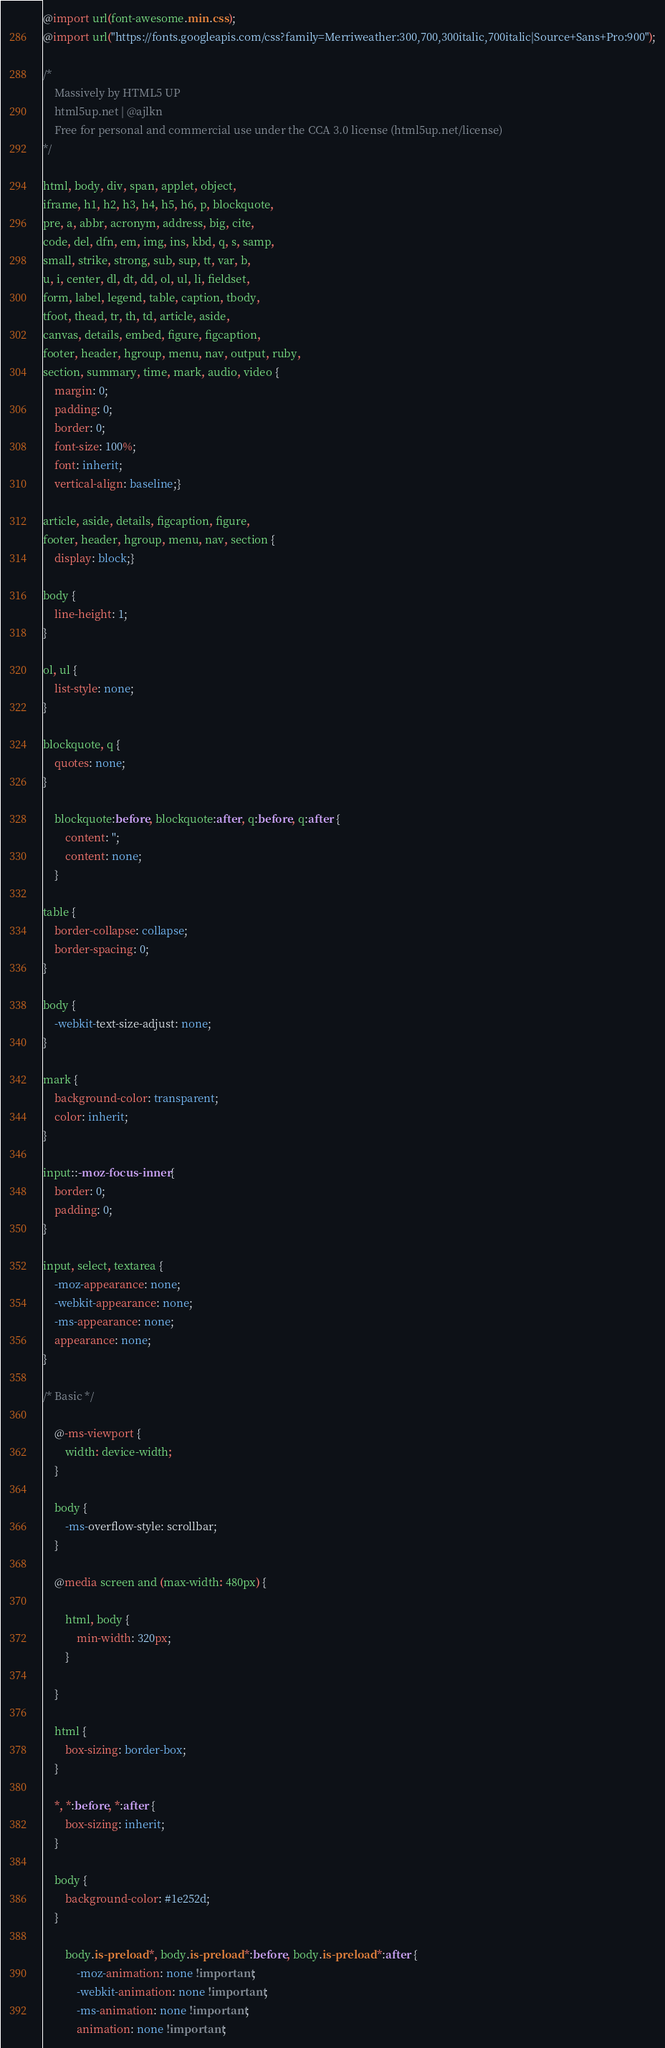<code> <loc_0><loc_0><loc_500><loc_500><_CSS_>@import url(font-awesome.min.css);
@import url("https://fonts.googleapis.com/css?family=Merriweather:300,700,300italic,700italic|Source+Sans+Pro:900");

/*
	Massively by HTML5 UP
	html5up.net | @ajlkn
	Free for personal and commercial use under the CCA 3.0 license (html5up.net/license)
*/

html, body, div, span, applet, object,
iframe, h1, h2, h3, h4, h5, h6, p, blockquote,
pre, a, abbr, acronym, address, big, cite,
code, del, dfn, em, img, ins, kbd, q, s, samp,
small, strike, strong, sub, sup, tt, var, b,
u, i, center, dl, dt, dd, ol, ul, li, fieldset,
form, label, legend, table, caption, tbody,
tfoot, thead, tr, th, td, article, aside,
canvas, details, embed, figure, figcaption,
footer, header, hgroup, menu, nav, output, ruby,
section, summary, time, mark, audio, video {
	margin: 0;
	padding: 0;
	border: 0;
	font-size: 100%;
	font: inherit;
	vertical-align: baseline;}

article, aside, details, figcaption, figure,
footer, header, hgroup, menu, nav, section {
	display: block;}

body {
	line-height: 1;
}

ol, ul {
	list-style: none;
}

blockquote, q {
	quotes: none;
}

	blockquote:before, blockquote:after, q:before, q:after {
		content: '';
		content: none;
	}

table {
	border-collapse: collapse;
	border-spacing: 0;
}

body {
	-webkit-text-size-adjust: none;
}

mark {
	background-color: transparent;
	color: inherit;
}

input::-moz-focus-inner {
	border: 0;
	padding: 0;
}

input, select, textarea {
	-moz-appearance: none;
	-webkit-appearance: none;
	-ms-appearance: none;
	appearance: none;
}

/* Basic */

	@-ms-viewport {
		width: device-width;
	}

	body {
		-ms-overflow-style: scrollbar;
	}

	@media screen and (max-width: 480px) {

		html, body {
			min-width: 320px;
		}

	}

	html {
		box-sizing: border-box;
	}

	*, *:before, *:after {
		box-sizing: inherit;
	}

	body {
		background-color: #1e252d;
	}

		body.is-preload *, body.is-preload *:before, body.is-preload *:after {
			-moz-animation: none !important;
			-webkit-animation: none !important;
			-ms-animation: none !important;
			animation: none !important;</code> 